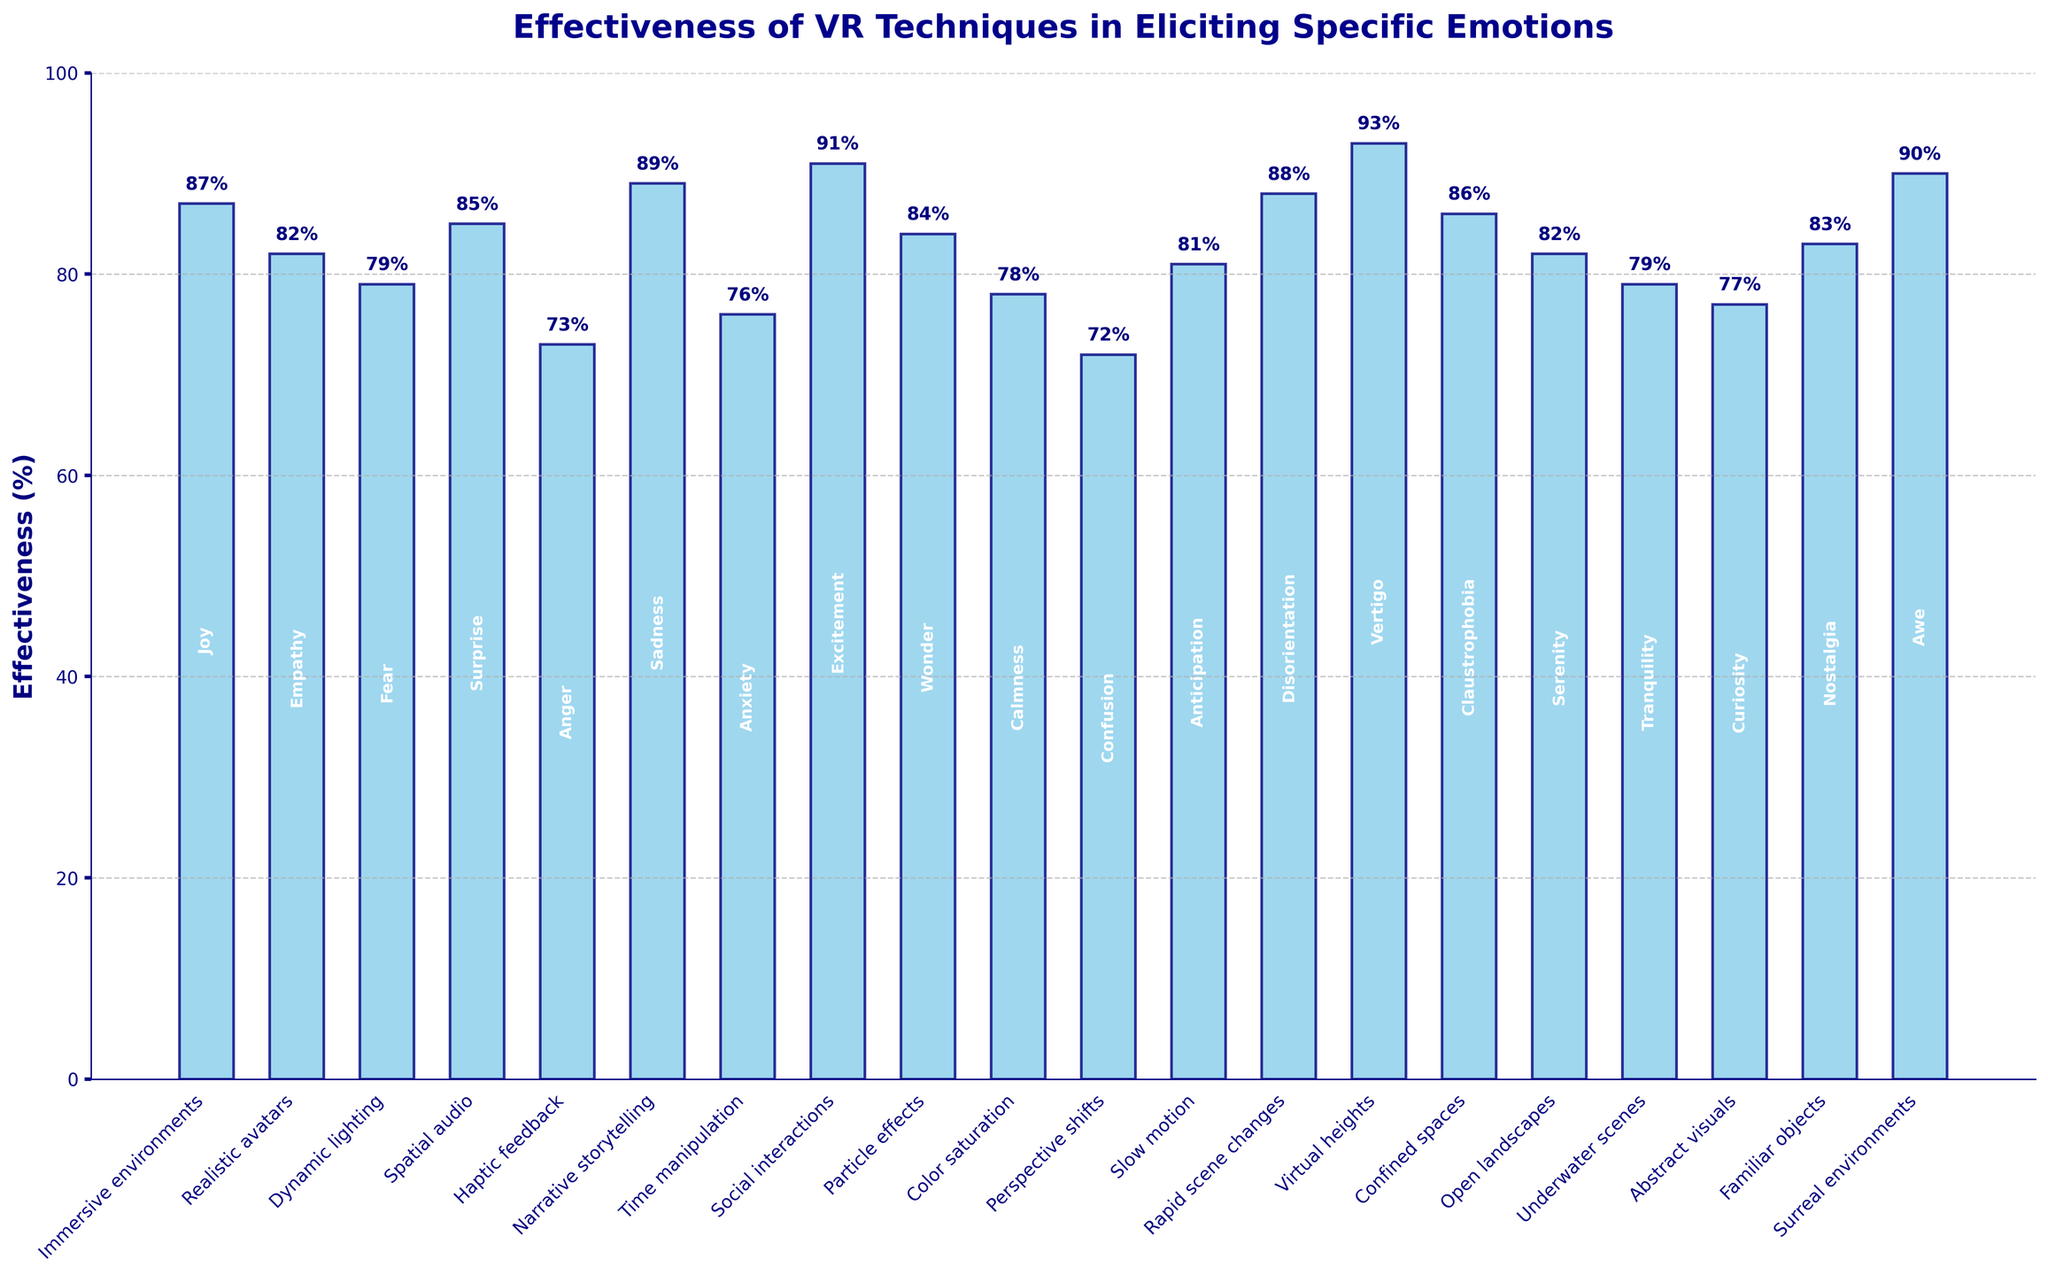Which technique is most effective in eliciting vertigo? The bar for "Virtual heights" reaches the highest point at 93%, indicating it is the most effective technique for eliciting vertigo.
Answer: Virtual heights What is the difference in effectiveness between narrative storytelling and dynamic lighting? Narrative storytelling has an effectiveness of 89%, while dynamic lighting has an effectiveness of 79%. Subtracting these values gives the difference: 89% - 79% = 10%.
Answer: 10% Which technique is more effective in eliciting surprise, spatial audio or time manipulation? Spatial audio has an effectiveness of 85%, and time manipulation has an effectiveness of 76%. Since 85% is greater than 76%, spatial audio is more effective.
Answer: Spatial audio What is the combined effectiveness percentage of immersive environments and social interactions? The effectiveness of immersive environments is 87% and social interactions is 91%. Adding these together gives: 87% + 91% = 178%.
Answer: 178% How does the effectiveness of rapid scene changes compare to confined spaces? Rapid scene changes have an effectiveness of 88%, while confined spaces have an effectiveness of 86%. Rapid scene changes are 2% more effective than confined spaces.
Answer: Rapid scene changes are 2% more effective Which emotion has the lowest effectiveness elicited by the associated technique? Confusion, elicited by perspective shifts, has the lowest effectiveness at 72%.
Answer: Confusion What is the average effectiveness of haptic feedback and spatial audio? The effectiveness of haptic feedback is 73% and spatial audio is 85%. The average is calculated as (73% + 85%) / 2 = 79%.
Answer: 79% Is the effectiveness of abstract visuals more or less than 80%? The effectiveness of abstract visuals is 77%, which is less than 80%.
Answer: Less By how much does the effectiveness of surreal environments exceed the effectiveness of underwater scenes? Surreal environments have an effectiveness of 90%, and underwater scenes have 79%. The difference is 90% - 79% = 11%.
Answer: 11% What is the effectiveness percentage of techniques that elicit either joy, empathy, or anger combined? The effectiveness for joy (immersive environments) is 87%, empathy (realistic avatars) is 82%, and anger (haptic feedback) is 73%. Summing these gives 87% + 82% + 73% = 242%.
Answer: 242% 